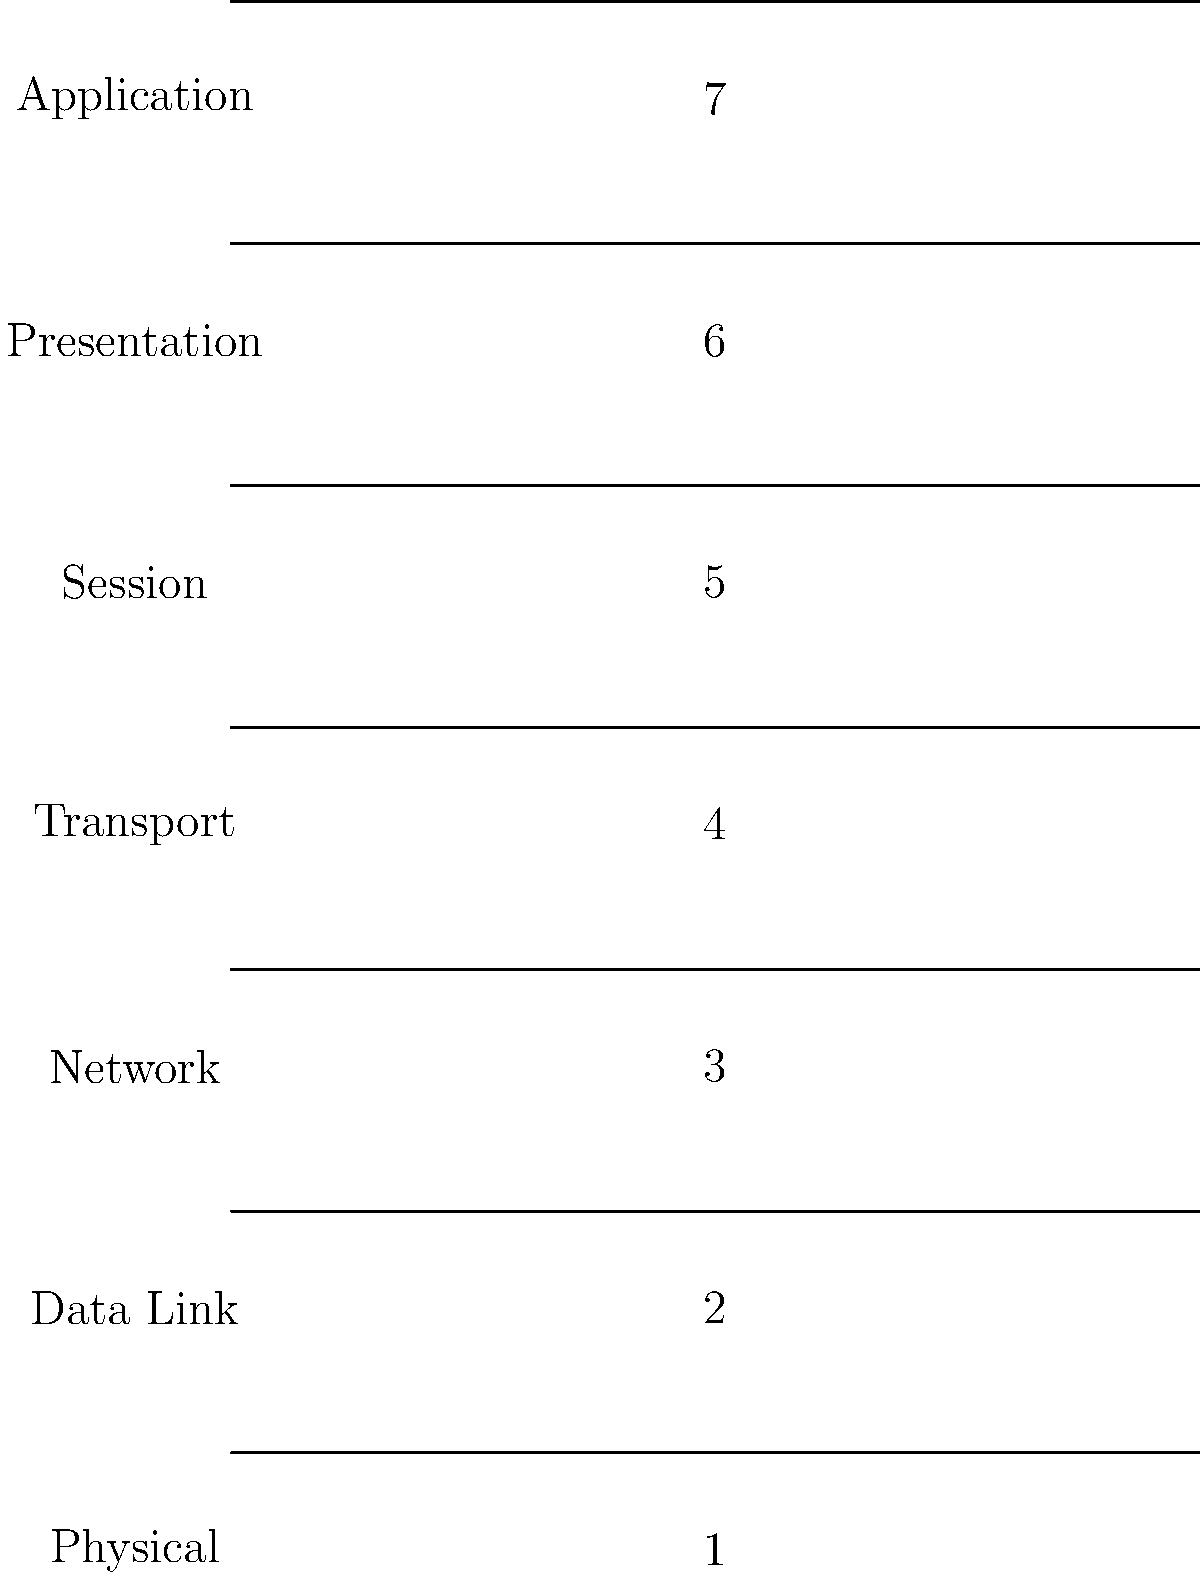As a web designer focused on internet security, which layer of the OSI model would you primarily be concerned with when implementing HTTPS (HTTP Secure) for a website to ensure secure communication between the client and server? To answer this question, let's break down the OSI model layers and their functions:

1. Physical Layer: Deals with physical transmission of data.
2. Data Link Layer: Handles error-free transfer of data frames.
3. Network Layer: Manages addressing and routing of data packets.
4. Transport Layer: Ensures end-to-end communication and data integrity.
5. Session Layer: Manages and terminates connections between applications.
6. Presentation Layer: Formats and encrypts data for the application layer.
7. Application Layer: Provides network services directly to end-users or applications.

HTTPS is a secure version of HTTP that uses encryption to protect data in transit. The primary security features of HTTPS are:

1. Encryption: Ensures that data cannot be read by unauthorized parties.
2. Data integrity: Prevents data tampering during transmission.
3. Authentication: Verifies the identity of the communicating parties.

These security features are primarily implemented at the Presentation Layer (Layer 6) of the OSI model. The Presentation Layer is responsible for data encryption, compression, and formatting before it's passed to the Application Layer.

In the context of HTTPS:
- The encryption is typically handled by TLS (Transport Layer Security) or its predecessor, SSL (Secure Sockets Layer).
- These protocols operate at the Presentation Layer, providing the security features required for HTTPS.

While the actual HTTPS protocol itself operates at the Application Layer (Layer 7), the crucial security mechanisms that make HTTPS secure are implemented at the Presentation Layer.

As a web designer focused on internet security, you would primarily be concerned with the Presentation Layer when implementing HTTPS, as this is where the essential security features are applied to protect the data exchanged between the client and the server.
Answer: Presentation Layer 